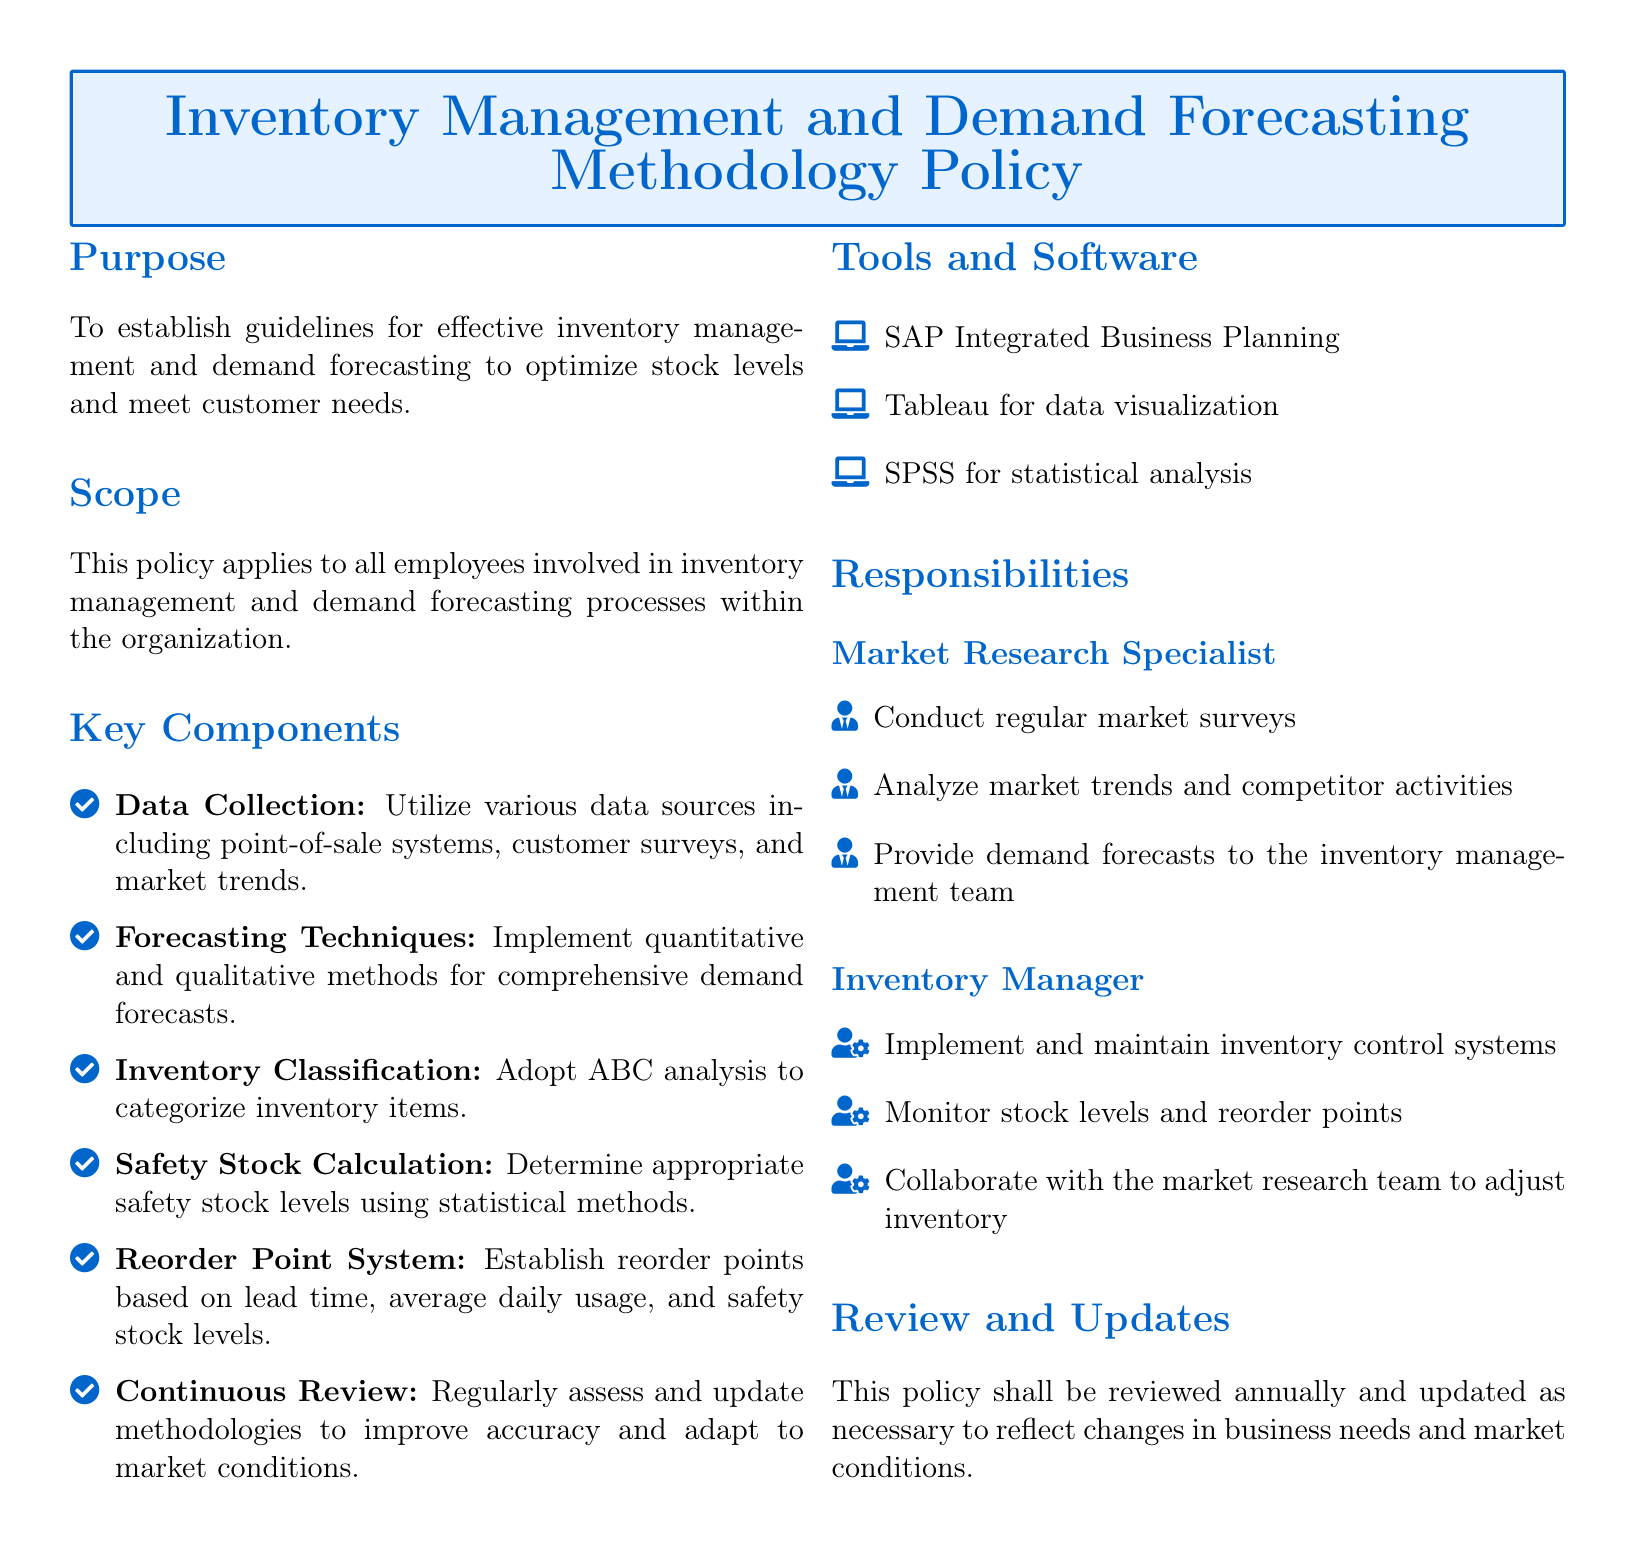What is the purpose of the policy? The policy aims to establish guidelines for effective inventory management and demand forecasting to optimize stock levels and meet customer needs.
Answer: To establish guidelines for effective inventory management and demand forecasting to optimize stock levels and meet customer needs Who is responsible for conducting regular market surveys? The document specifies that the Market Research Specialist is responsible for conducting regular market surveys.
Answer: Market Research Specialist What software is mentioned for statistical analysis? The document lists SPSS as the tool for statistical analysis under the Tools and Software section.
Answer: SPSS What method is used for categorizing inventory items? ABC analysis is mentioned in the Key Components as the method for classifying inventory items.
Answer: ABC analysis How often should the policy be reviewed? The document states that this policy shall be reviewed annually, indicating the frequency of review.
Answer: Annually What is the role of the Inventory Manager? The document outlines that the Inventory Manager is responsible for implementing and maintaining inventory control systems.
Answer: Implement and maintain inventory control systems What is included in data collection? The Key Components section notes various data sources, including point-of-sale systems and customer surveys.
Answer: Point-of-sale systems, customer surveys What is the first component listed in the Key Components section? The first component listed is Data Collection in the Key Components section.
Answer: Data Collection What is a method for calculating safety stock levels? The document mentions that safety stock levels should be determined using statistical methods.
Answer: Statistical methods 